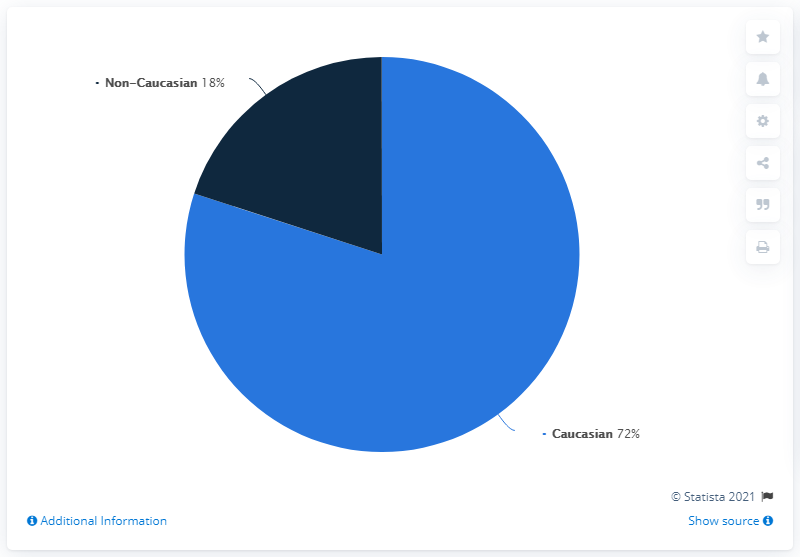Outline some significant characteristics in this image. The blue segment is four times the area of the navy blue one. The share of Caucasian golfers is 72%. In 2018, 72% of golfers in the United States identified as Caucasian. 